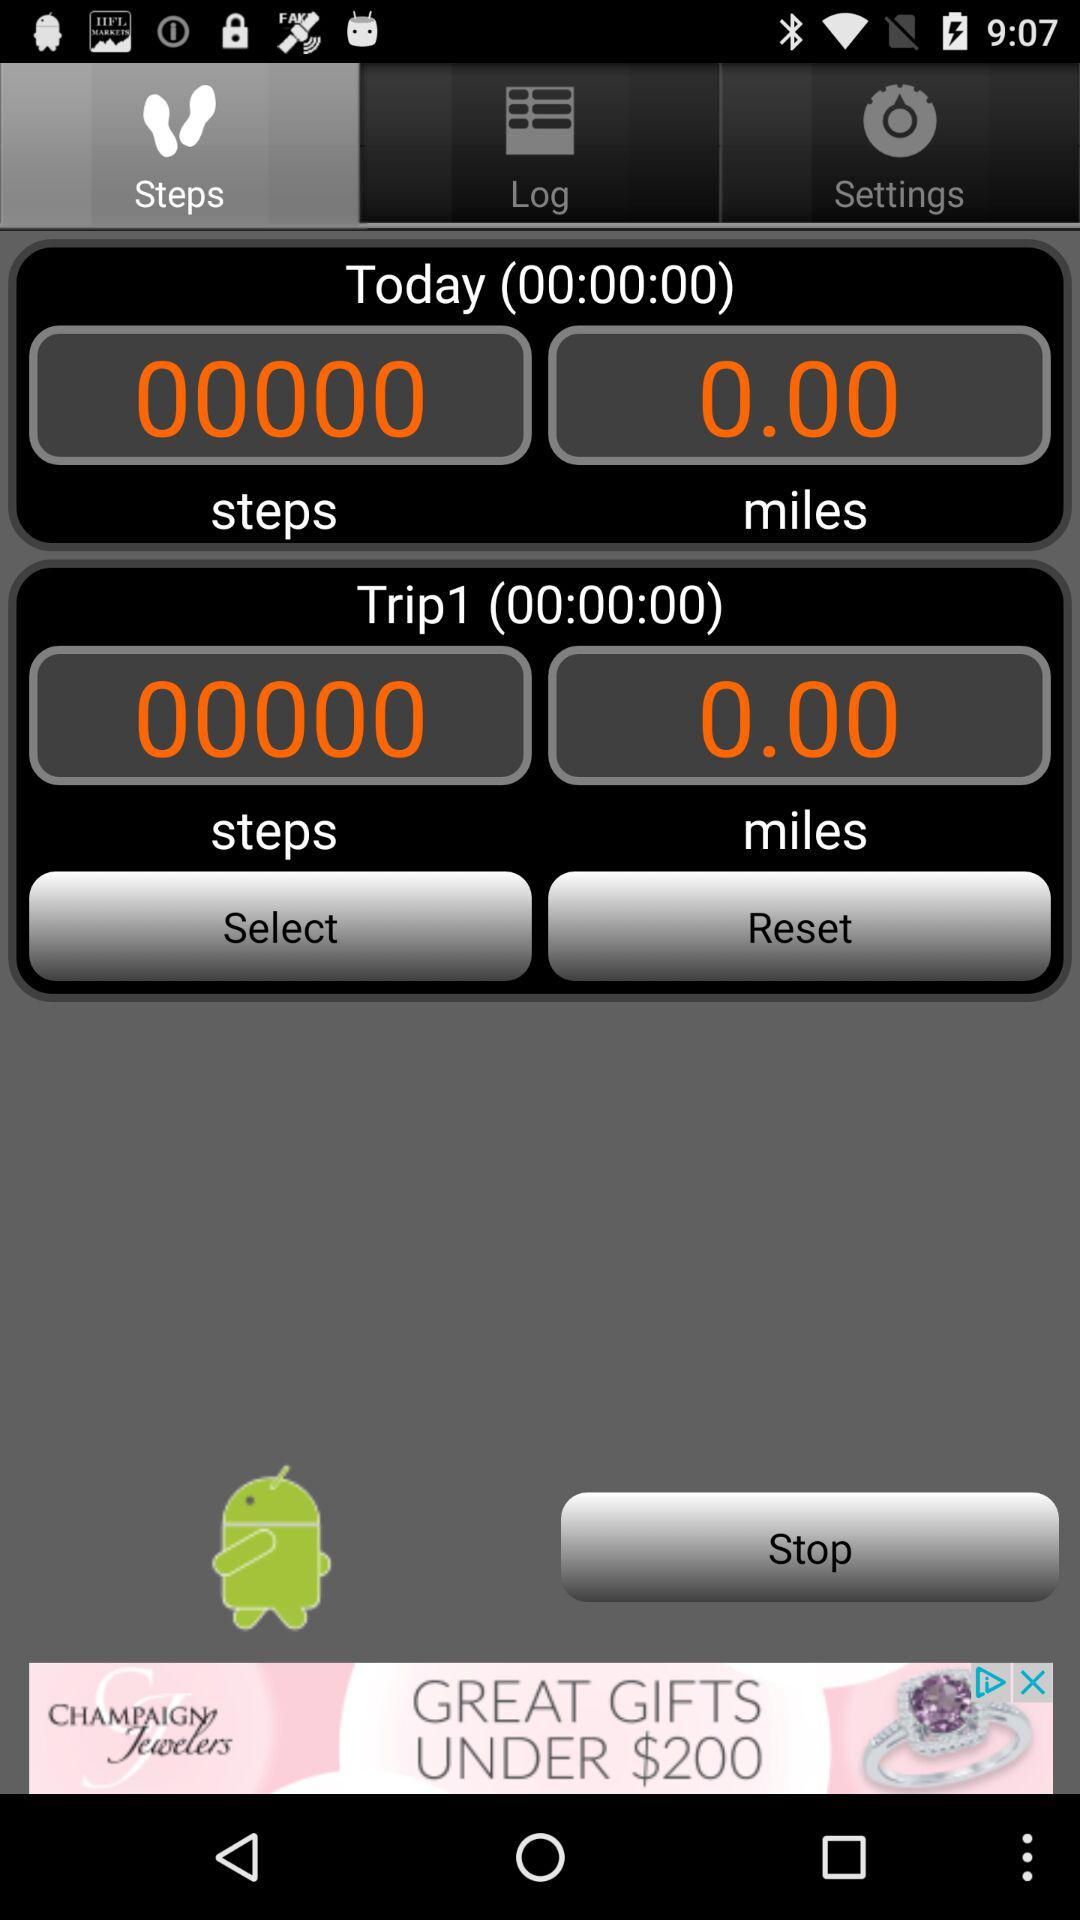What is the number of steps that were completed today? The number of steps that were completed today is 0. 